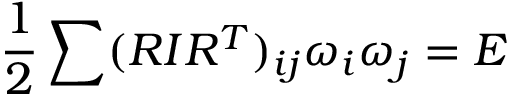<formula> <loc_0><loc_0><loc_500><loc_500>\frac { 1 } { 2 } \sum ( R I R ^ { T } ) _ { i j } \omega _ { i } \omega _ { j } = E</formula> 